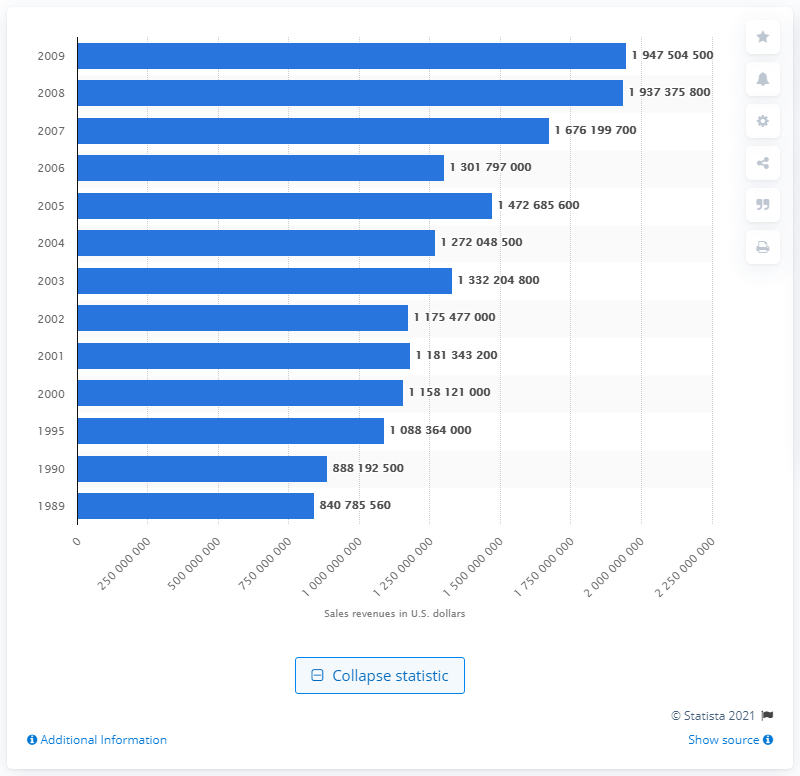List a handful of essential elements in this visual. In 2005, the revenues from salt sales in the United States were approximately 147,268,560. 